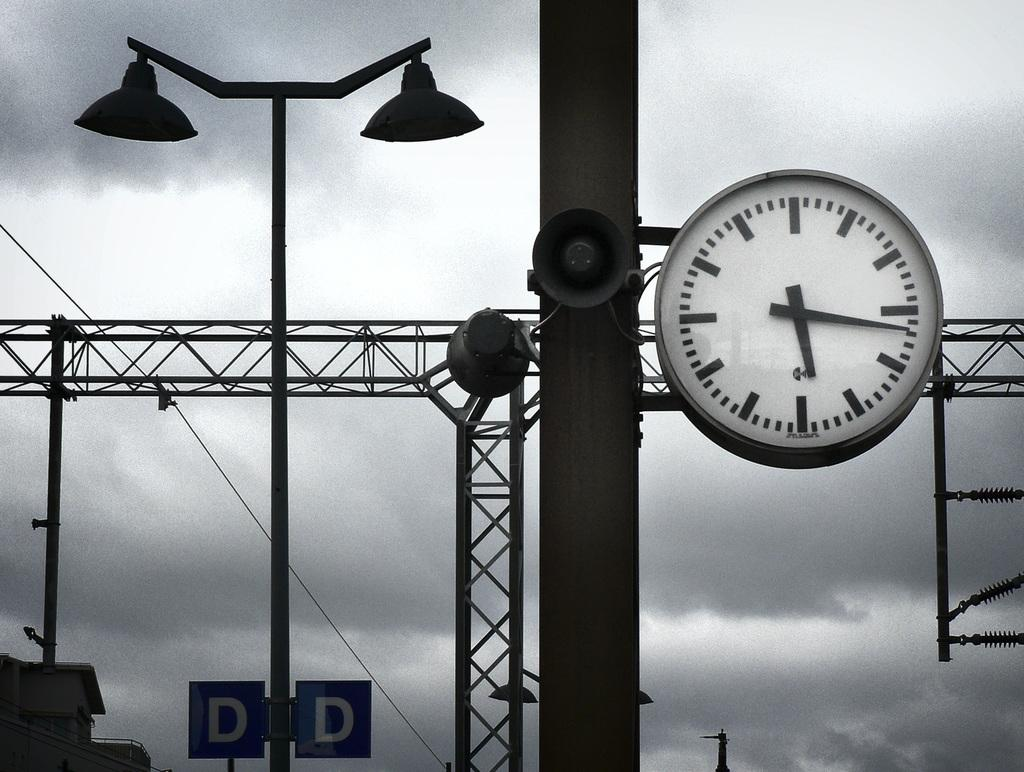<image>
Share a concise interpretation of the image provided. A blue sign shows the letters "D" and "D" below a lamp. 